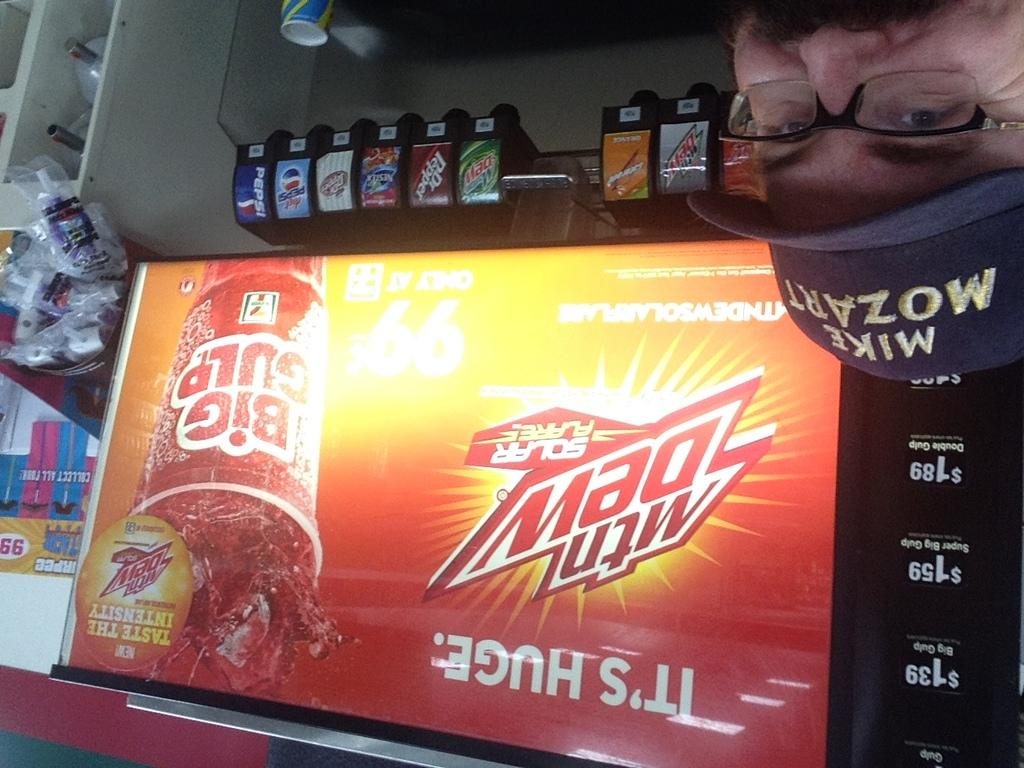Provide a one-sentence caption for the provided image. A soda fountain that has an ad for Mountain Dew on it. 